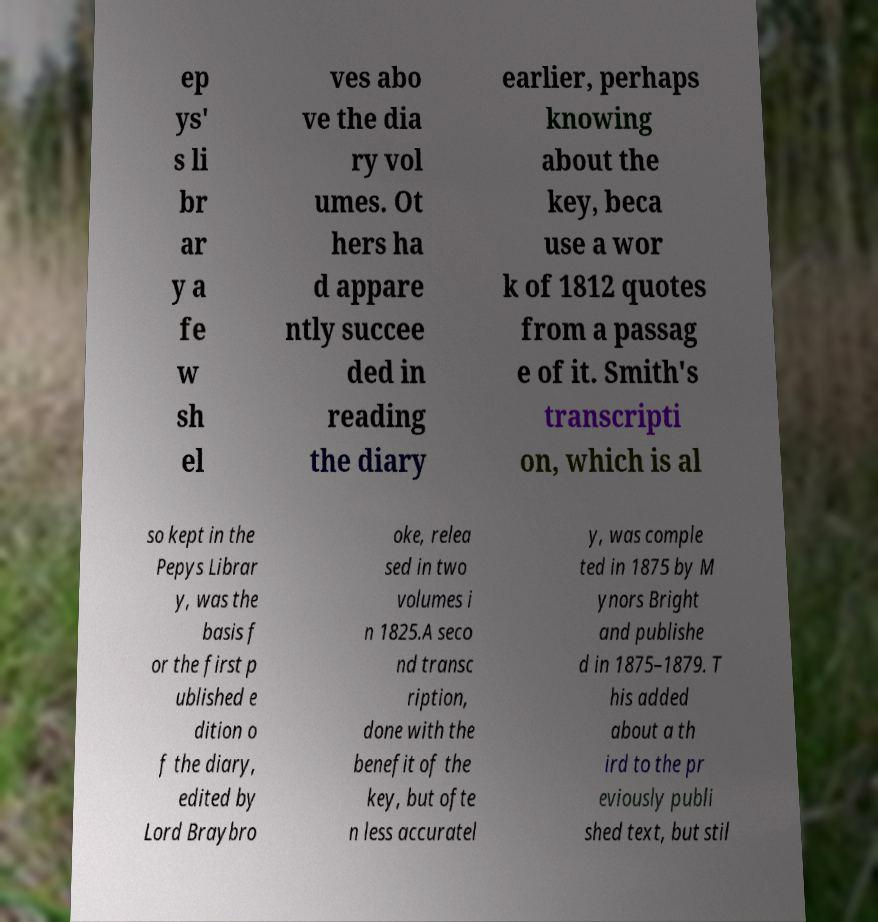Can you accurately transcribe the text from the provided image for me? ep ys' s li br ar y a fe w sh el ves abo ve the dia ry vol umes. Ot hers ha d appare ntly succee ded in reading the diary earlier, perhaps knowing about the key, beca use a wor k of 1812 quotes from a passag e of it. Smith's transcripti on, which is al so kept in the Pepys Librar y, was the basis f or the first p ublished e dition o f the diary, edited by Lord Braybro oke, relea sed in two volumes i n 1825.A seco nd transc ription, done with the benefit of the key, but ofte n less accuratel y, was comple ted in 1875 by M ynors Bright and publishe d in 1875–1879. T his added about a th ird to the pr eviously publi shed text, but stil 